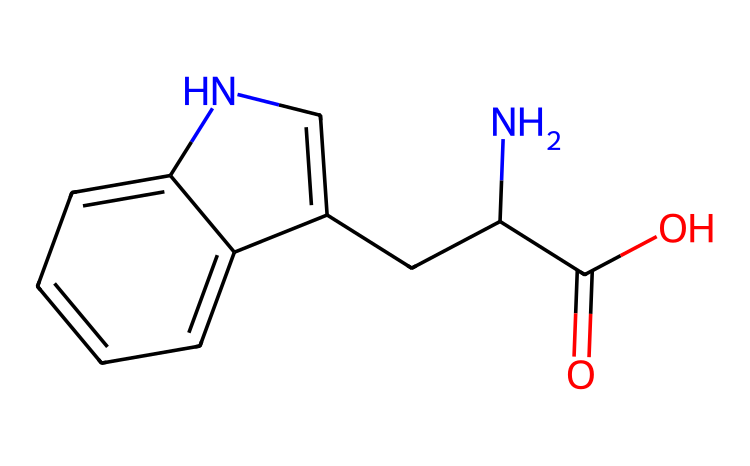What is the molecular formula of tryptophan? To determine the molecular formula, we can count the number of each type of atom in the molecular structure represented by the SMILES code. In this case, the structure contains 11 carbon (C) atoms, 12 hydrogen (H) atoms, 2 nitrogen (N) atoms, and 2 oxygen (O) atoms. Putting this together gives the molecular formula C11H12N2O2.
Answer: C11H12N2O2 How many chiral centers are present in tryptophan? A chiral center is a carbon atom that is attached to four different groups. In the case of tryptophan, we analyze the structure and identify that there is one chiral carbon located within the amino acid backbone. This is the carbon atom attached to the amino group, carboxylic acid, hydrogen, and the side chain (indole ring).
Answer: 1 What is the functional group present in the carboxylic acid section of tryptophan? The carboxylic acid functional group includes a carbon atom double-bonded to an oxygen atom and single-bonded to a hydroxyl group (–COOH). In the tryptophan structure, the presence of this –COOH indicates the carboxylic acid functional group.
Answer: carboxylic acid What is the nature of the side chain in tryptophan? The side chain of tryptophan is an indole ring structure, which is characterized by a fused benzene and pyrrole ring. This specific structure contributes to the biochemical properties and functions of tryptophan in the body, particularly its involvement in serotonin synthesis.
Answer: indole Can tryptophan exist in multiple stereoisomeric forms? Since tryptophan contains one chiral center, it can exist in two stereoisomeric forms: L-tryptophan and D-tryptophan. These different forms can exhibit varied biological activities. The presence of the chiral center allows for these stereoisomers to be non-superimposable mirror images of each other.
Answer: yes How does tryptophan affect mood? Tryptophan is a precursor to serotonin, a neurotransmitter that plays a key role in mood regulation. Increased levels of serotonin derived from tryptophan can improve mood and possibly enhance productivity too. The biochemical pathway linking tryptophan to serotonin synthesis exemplifies this effect.
Answer: improves mood 